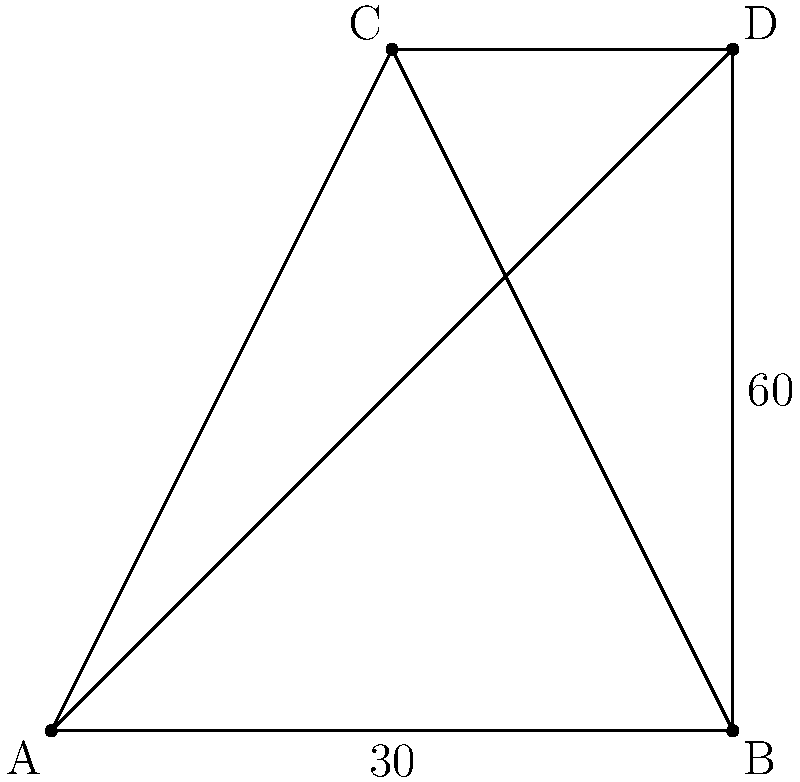During a tactical analysis of a football match at Bath City FC, you're asked to calculate the angle formed by the intersection of two diagonal lines on the pitch. Given that the angle at point B is $30°$ and the angle at point D is $60°$, what is the angle formed at the intersection point of AC and BD? Let's approach this step-by-step:

1) First, recall that the sum of angles in a triangle is always $180°$.

2) In triangle ABD:
   - We know $\angle BAD = 30°$
   - We know $\angle ADB = 60°$
   - Let $\angle ABD = x$
   
   Therefore, $30° + 60° + x = 180°$
   $90° + x = 180°$
   $x = 90°$

3) Now, we have two intersecting lines AC and BD. We know that when two lines intersect, opposite angles are equal.

4) The angle we're looking for is opposite to $\angle ADB$, which we know is $60°$.

Therefore, the angle formed at the intersection point of AC and BD is also $60°$.
Answer: $60°$ 